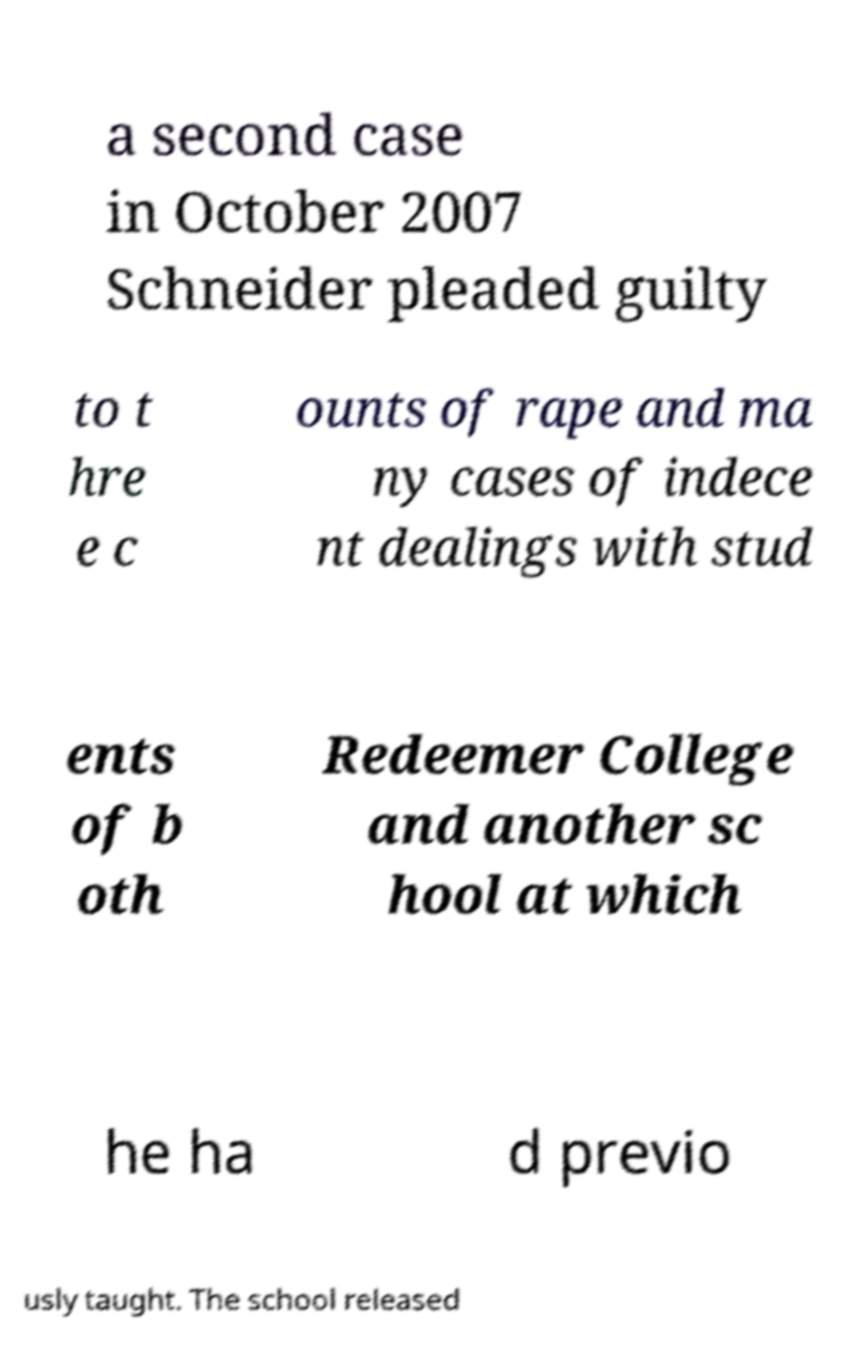There's text embedded in this image that I need extracted. Can you transcribe it verbatim? a second case in October 2007 Schneider pleaded guilty to t hre e c ounts of rape and ma ny cases of indece nt dealings with stud ents of b oth Redeemer College and another sc hool at which he ha d previo usly taught. The school released 